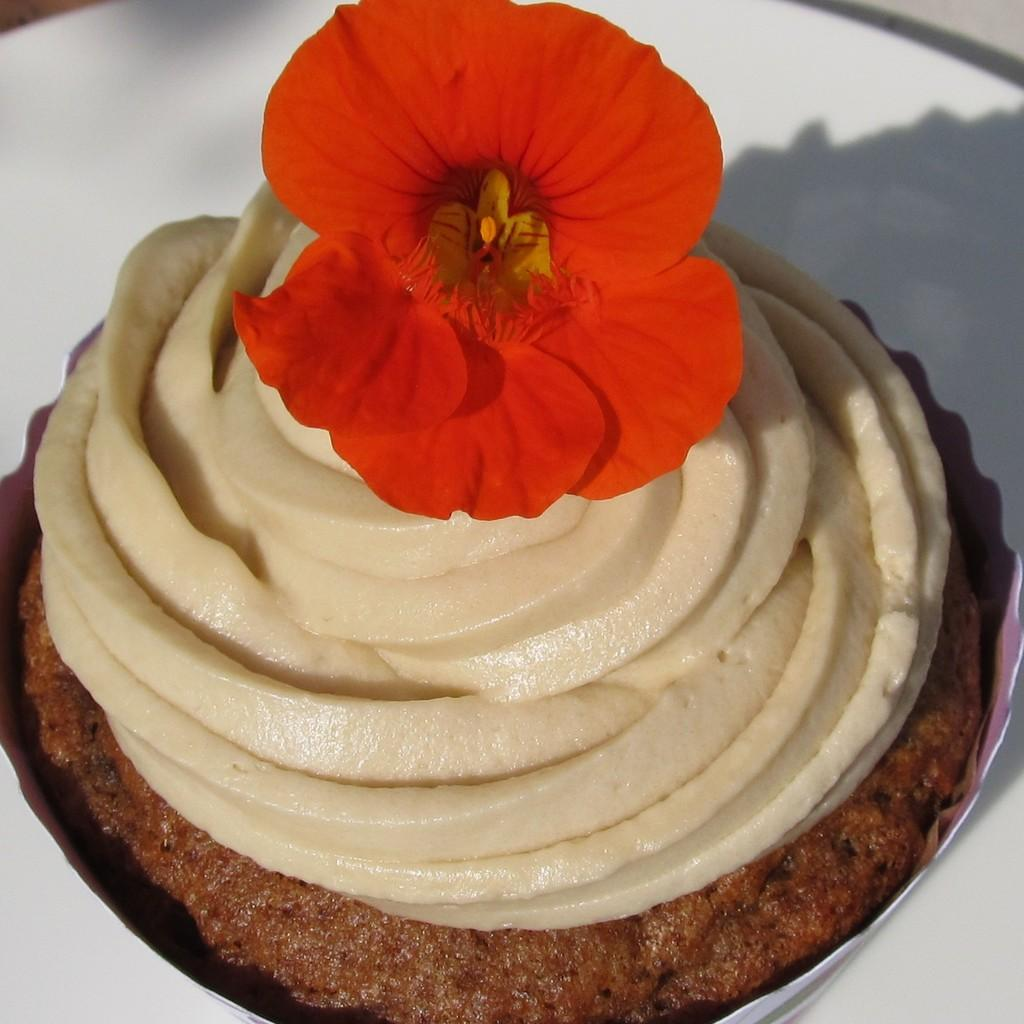What is on the plate in the image? There is a cake on the plate in the image. What decoration is on the cake? There is a flower on the cake. What type of advertisement is on the cake in the image? There is no advertisement on the cake in the image; it features a flower as a decoration. 